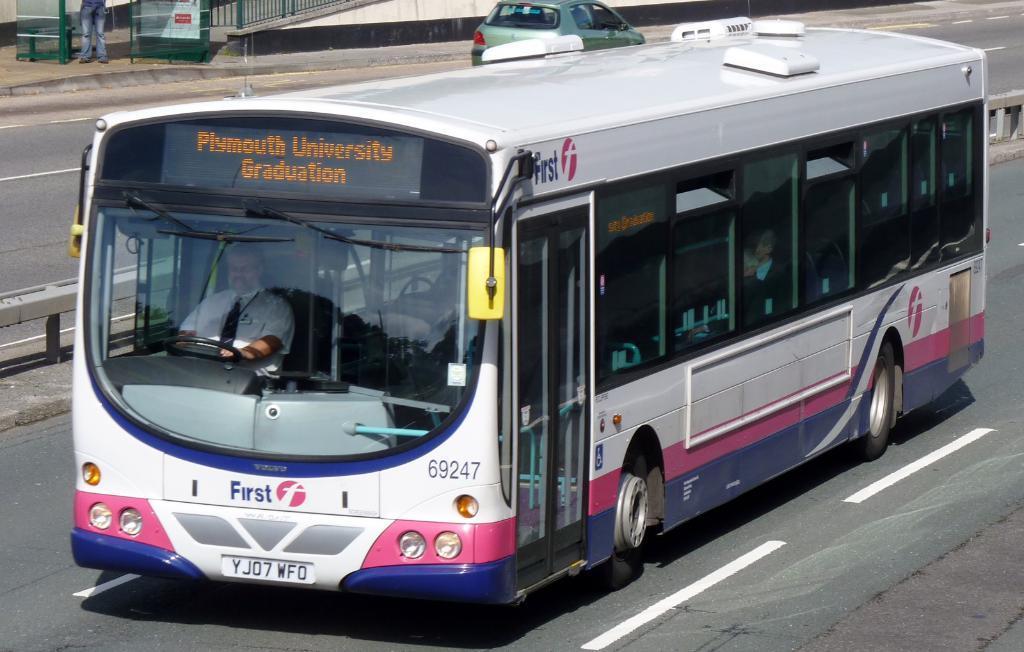How would you summarize this image in a sentence or two? In this image we can see a bus and a car on the road, there is a person driving the bus and on the left side there is an iron fence and a person legs. 